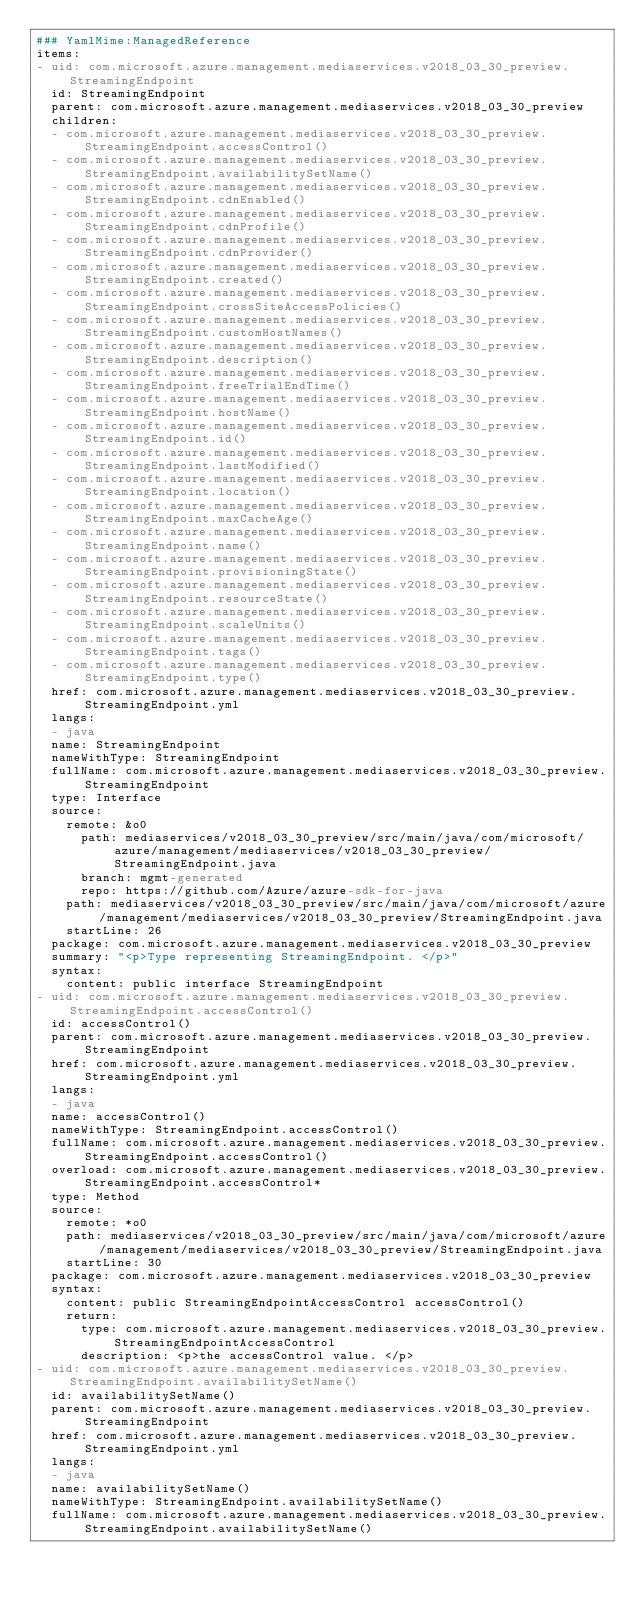<code> <loc_0><loc_0><loc_500><loc_500><_YAML_>### YamlMime:ManagedReference
items:
- uid: com.microsoft.azure.management.mediaservices.v2018_03_30_preview.StreamingEndpoint
  id: StreamingEndpoint
  parent: com.microsoft.azure.management.mediaservices.v2018_03_30_preview
  children:
  - com.microsoft.azure.management.mediaservices.v2018_03_30_preview.StreamingEndpoint.accessControl()
  - com.microsoft.azure.management.mediaservices.v2018_03_30_preview.StreamingEndpoint.availabilitySetName()
  - com.microsoft.azure.management.mediaservices.v2018_03_30_preview.StreamingEndpoint.cdnEnabled()
  - com.microsoft.azure.management.mediaservices.v2018_03_30_preview.StreamingEndpoint.cdnProfile()
  - com.microsoft.azure.management.mediaservices.v2018_03_30_preview.StreamingEndpoint.cdnProvider()
  - com.microsoft.azure.management.mediaservices.v2018_03_30_preview.StreamingEndpoint.created()
  - com.microsoft.azure.management.mediaservices.v2018_03_30_preview.StreamingEndpoint.crossSiteAccessPolicies()
  - com.microsoft.azure.management.mediaservices.v2018_03_30_preview.StreamingEndpoint.customHostNames()
  - com.microsoft.azure.management.mediaservices.v2018_03_30_preview.StreamingEndpoint.description()
  - com.microsoft.azure.management.mediaservices.v2018_03_30_preview.StreamingEndpoint.freeTrialEndTime()
  - com.microsoft.azure.management.mediaservices.v2018_03_30_preview.StreamingEndpoint.hostName()
  - com.microsoft.azure.management.mediaservices.v2018_03_30_preview.StreamingEndpoint.id()
  - com.microsoft.azure.management.mediaservices.v2018_03_30_preview.StreamingEndpoint.lastModified()
  - com.microsoft.azure.management.mediaservices.v2018_03_30_preview.StreamingEndpoint.location()
  - com.microsoft.azure.management.mediaservices.v2018_03_30_preview.StreamingEndpoint.maxCacheAge()
  - com.microsoft.azure.management.mediaservices.v2018_03_30_preview.StreamingEndpoint.name()
  - com.microsoft.azure.management.mediaservices.v2018_03_30_preview.StreamingEndpoint.provisioningState()
  - com.microsoft.azure.management.mediaservices.v2018_03_30_preview.StreamingEndpoint.resourceState()
  - com.microsoft.azure.management.mediaservices.v2018_03_30_preview.StreamingEndpoint.scaleUnits()
  - com.microsoft.azure.management.mediaservices.v2018_03_30_preview.StreamingEndpoint.tags()
  - com.microsoft.azure.management.mediaservices.v2018_03_30_preview.StreamingEndpoint.type()
  href: com.microsoft.azure.management.mediaservices.v2018_03_30_preview.StreamingEndpoint.yml
  langs:
  - java
  name: StreamingEndpoint
  nameWithType: StreamingEndpoint
  fullName: com.microsoft.azure.management.mediaservices.v2018_03_30_preview.StreamingEndpoint
  type: Interface
  source:
    remote: &o0
      path: mediaservices/v2018_03_30_preview/src/main/java/com/microsoft/azure/management/mediaservices/v2018_03_30_preview/StreamingEndpoint.java
      branch: mgmt-generated
      repo: https://github.com/Azure/azure-sdk-for-java
    path: mediaservices/v2018_03_30_preview/src/main/java/com/microsoft/azure/management/mediaservices/v2018_03_30_preview/StreamingEndpoint.java
    startLine: 26
  package: com.microsoft.azure.management.mediaservices.v2018_03_30_preview
  summary: "<p>Type representing StreamingEndpoint. </p>"
  syntax:
    content: public interface StreamingEndpoint
- uid: com.microsoft.azure.management.mediaservices.v2018_03_30_preview.StreamingEndpoint.accessControl()
  id: accessControl()
  parent: com.microsoft.azure.management.mediaservices.v2018_03_30_preview.StreamingEndpoint
  href: com.microsoft.azure.management.mediaservices.v2018_03_30_preview.StreamingEndpoint.yml
  langs:
  - java
  name: accessControl()
  nameWithType: StreamingEndpoint.accessControl()
  fullName: com.microsoft.azure.management.mediaservices.v2018_03_30_preview.StreamingEndpoint.accessControl()
  overload: com.microsoft.azure.management.mediaservices.v2018_03_30_preview.StreamingEndpoint.accessControl*
  type: Method
  source:
    remote: *o0
    path: mediaservices/v2018_03_30_preview/src/main/java/com/microsoft/azure/management/mediaservices/v2018_03_30_preview/StreamingEndpoint.java
    startLine: 30
  package: com.microsoft.azure.management.mediaservices.v2018_03_30_preview
  syntax:
    content: public StreamingEndpointAccessControl accessControl()
    return:
      type: com.microsoft.azure.management.mediaservices.v2018_03_30_preview.StreamingEndpointAccessControl
      description: <p>the accessControl value. </p>
- uid: com.microsoft.azure.management.mediaservices.v2018_03_30_preview.StreamingEndpoint.availabilitySetName()
  id: availabilitySetName()
  parent: com.microsoft.azure.management.mediaservices.v2018_03_30_preview.StreamingEndpoint
  href: com.microsoft.azure.management.mediaservices.v2018_03_30_preview.StreamingEndpoint.yml
  langs:
  - java
  name: availabilitySetName()
  nameWithType: StreamingEndpoint.availabilitySetName()
  fullName: com.microsoft.azure.management.mediaservices.v2018_03_30_preview.StreamingEndpoint.availabilitySetName()</code> 